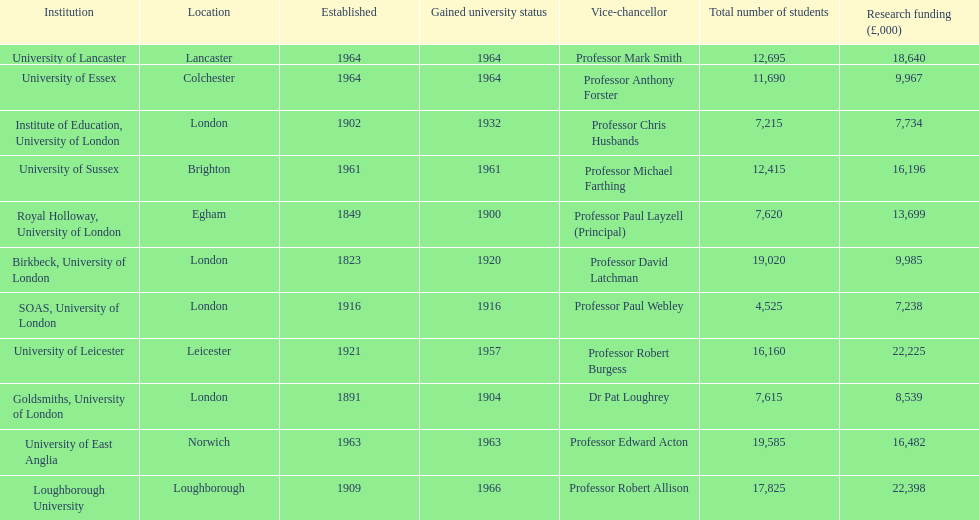Which institution has the most research funding? Loughborough University. Could you help me parse every detail presented in this table? {'header': ['Institution', 'Location', 'Established', 'Gained university status', 'Vice-chancellor', 'Total number of students', 'Research funding (£,000)'], 'rows': [['University of Lancaster', 'Lancaster', '1964', '1964', 'Professor Mark Smith', '12,695', '18,640'], ['University of Essex', 'Colchester', '1964', '1964', 'Professor Anthony Forster', '11,690', '9,967'], ['Institute of Education, University of London', 'London', '1902', '1932', 'Professor Chris Husbands', '7,215', '7,734'], ['University of Sussex', 'Brighton', '1961', '1961', 'Professor Michael Farthing', '12,415', '16,196'], ['Royal Holloway, University of London', 'Egham', '1849', '1900', 'Professor Paul Layzell (Principal)', '7,620', '13,699'], ['Birkbeck, University of London', 'London', '1823', '1920', 'Professor David Latchman', '19,020', '9,985'], ['SOAS, University of London', 'London', '1916', '1916', 'Professor Paul Webley', '4,525', '7,238'], ['University of Leicester', 'Leicester', '1921', '1957', 'Professor Robert Burgess', '16,160', '22,225'], ['Goldsmiths, University of London', 'London', '1891', '1904', 'Dr Pat Loughrey', '7,615', '8,539'], ['University of East Anglia', 'Norwich', '1963', '1963', 'Professor Edward Acton', '19,585', '16,482'], ['Loughborough University', 'Loughborough', '1909', '1966', 'Professor Robert Allison', '17,825', '22,398']]} 